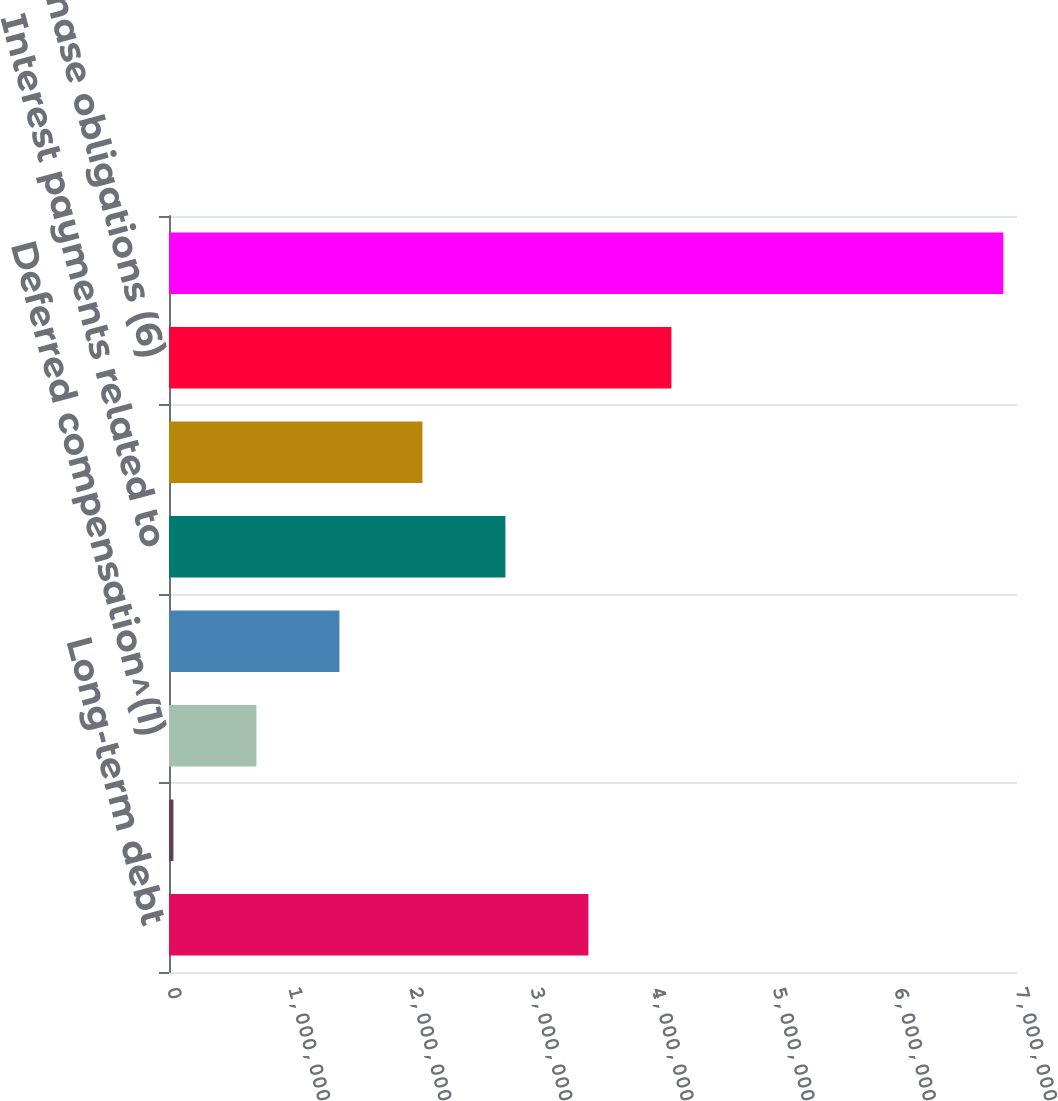<chart> <loc_0><loc_0><loc_500><loc_500><bar_chart><fcel>Long-term debt<fcel>Capital lease obligations<fcel>Deferred compensation^(1)<fcel>SERP and other postretirement<fcel>Interest payments related to<fcel>Long-term non-capitalized<fcel>Purchase obligations (6)<fcel>Total contractual cash<nl><fcel>3.46208e+06<fcel>36620<fcel>721713<fcel>1.40681e+06<fcel>2.77699e+06<fcel>2.0919e+06<fcel>4.14718e+06<fcel>6.88755e+06<nl></chart> 